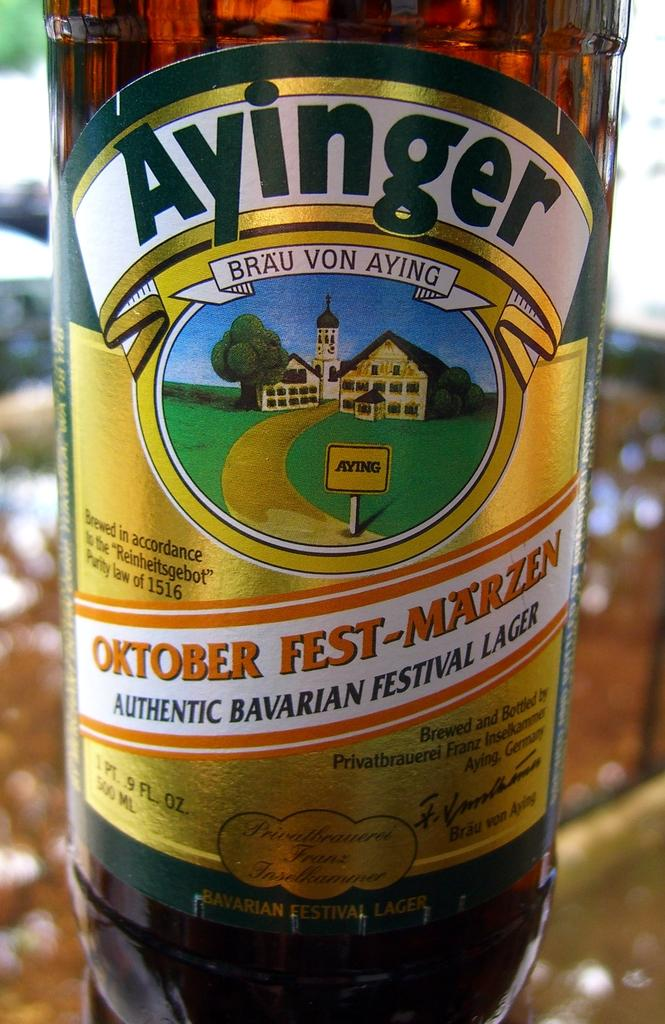<image>
Create a compact narrative representing the image presented. A bottle of Ayinger Oktober Fest-Marzen Authentic Bavarian Festival Lager. 